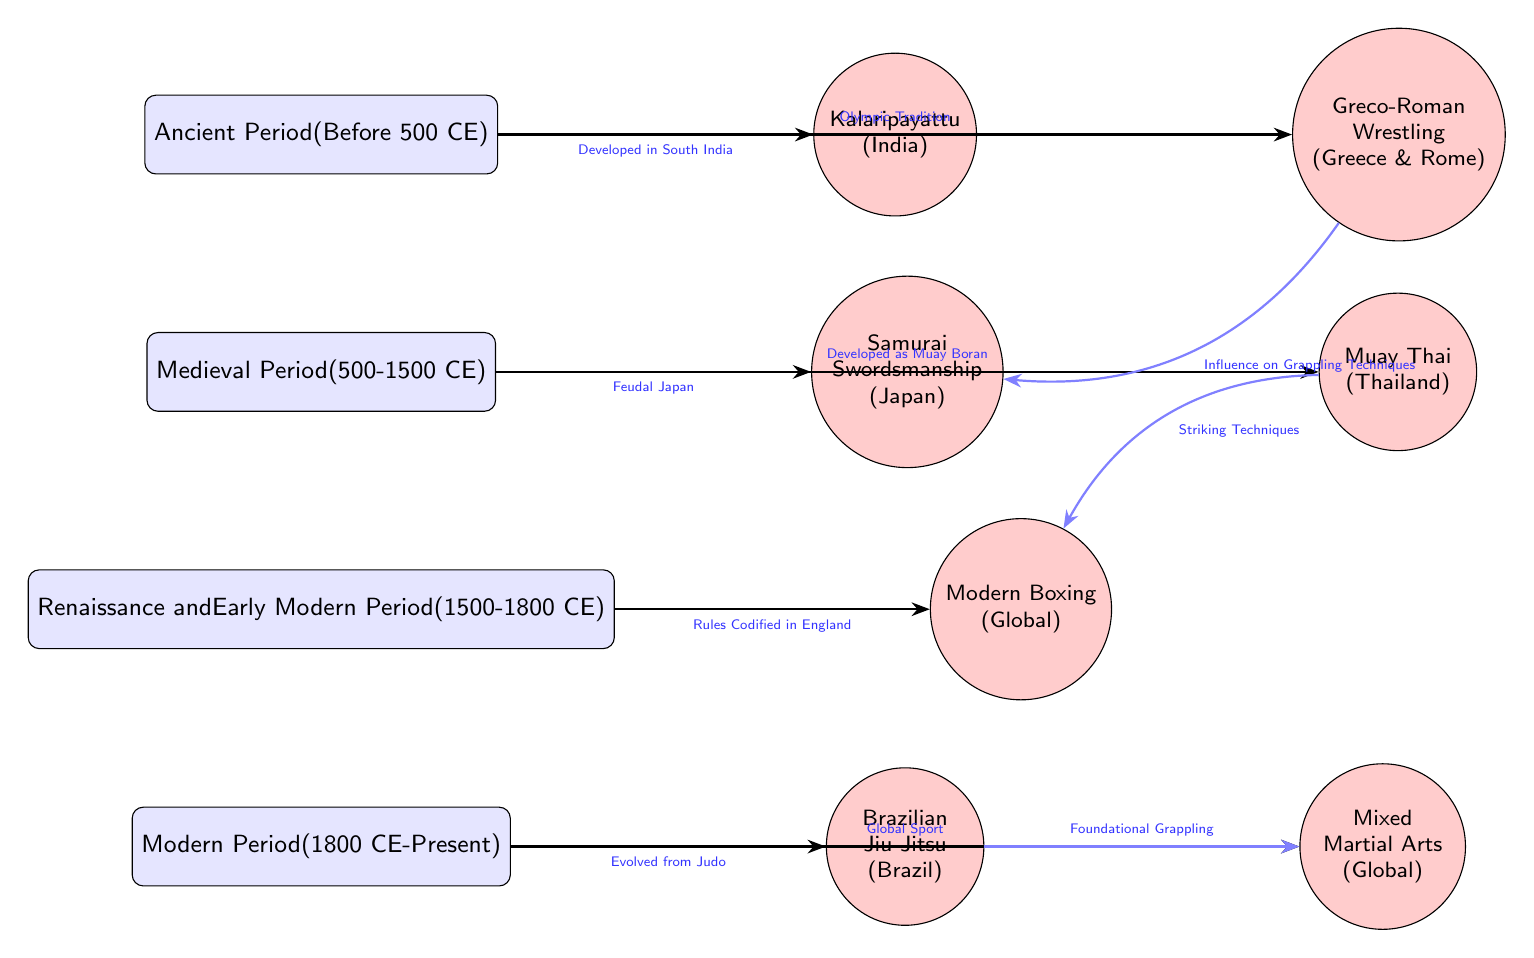What martial art is associated with the Ancient Period? The diagram shows Kalaripayattu linked to the Ancient Period node, indicating it was developed during this time.
Answer: Kalaripayattu What time period does Modern Boxing belong to? Modern Boxing is connected to the Renaissance and Early Modern Period node, indicating it was formalized during this time.
Answer: Renaissance and Early Modern Period How many martial arts are connected to the Medieval Period? The Medieval Period node has two martial arts connected to it: Samurai Swordsmanship and Muay Thai.
Answer: 2 What technique influenced Mixed Martial Arts? The diagram shows that Brazilian Jiu-Jitsu is a foundational grappling art that influenced Mixed Martial Arts.
Answer: Foundational Grappling Which martial art developed from Judo? The diagram indicates that Brazilian Jiu-Jitsu evolved from Judo, as shown by the arrow connecting them.
Answer: Brazilian Jiu-Jitsu What is the historical context of Muay Thai? Muay Thai is derived from Muay Boran, as indicated by the arrow explaining its development in the Medieval Period.
Answer: Developed as Muay Boran How are Greco-Roman Wrestling and Samurai Swordsmanship related? The diagram indicates that Greco-Roman Wrestling influenced grappling techniques used in Samurai Swordsmanship, revealing their connection.
Answer: Influence on Grappling Techniques What is the timeline range for the Ancient Period? The diagram describes the Ancient Period as being before 500 CE, specifying the time frame for this era.
Answer: Before 500 CE What influencing factor connects Muay Thai and Modern Boxing? The diagram highlights that Muay Thai contributes striking techniques to Modern Boxing, establishing a link between the two.
Answer: Striking Techniques 